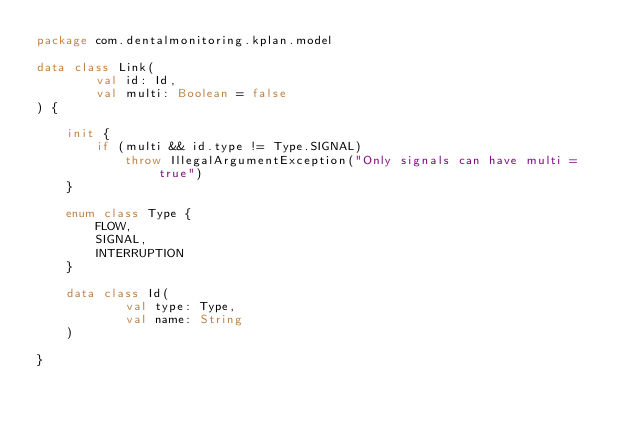Convert code to text. <code><loc_0><loc_0><loc_500><loc_500><_Kotlin_>package com.dentalmonitoring.kplan.model

data class Link(
        val id: Id,
        val multi: Boolean = false
) {

    init {
        if (multi && id.type != Type.SIGNAL)
            throw IllegalArgumentException("Only signals can have multi = true")
    }

    enum class Type {
        FLOW,
        SIGNAL,
        INTERRUPTION
    }

    data class Id(
            val type: Type,
            val name: String
    )

}
</code> 